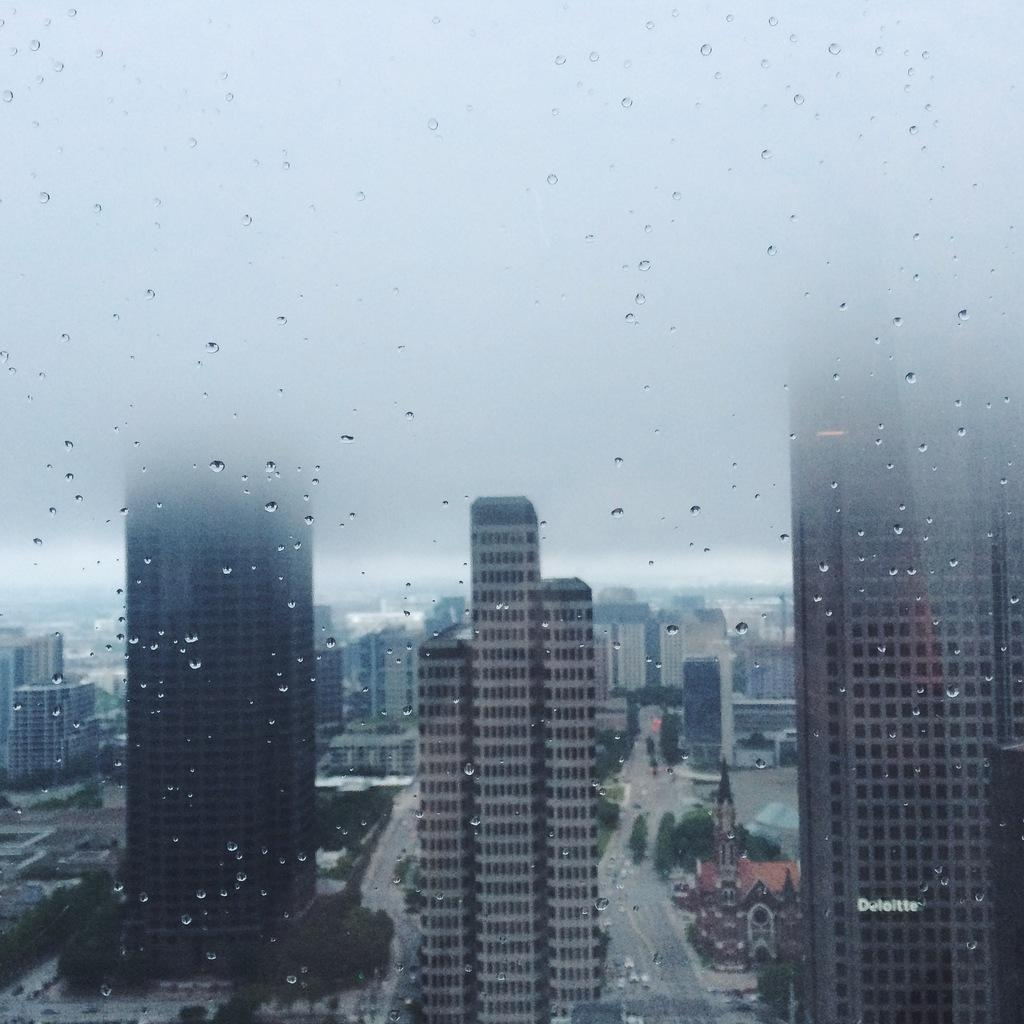What can be seen on the glass in the image? There are water droplets on the glass in the image. What is visible beyond the glass? Buildings, vehicles on the road, trees, and the sky are visible through the glass. What type of cabbage is the farmer holding in the image? There is no farmer or cabbage present in the image. What noise can be heard coming from the vehicles in the image? The image is a still picture, so no noise can be heard from the vehicles. 